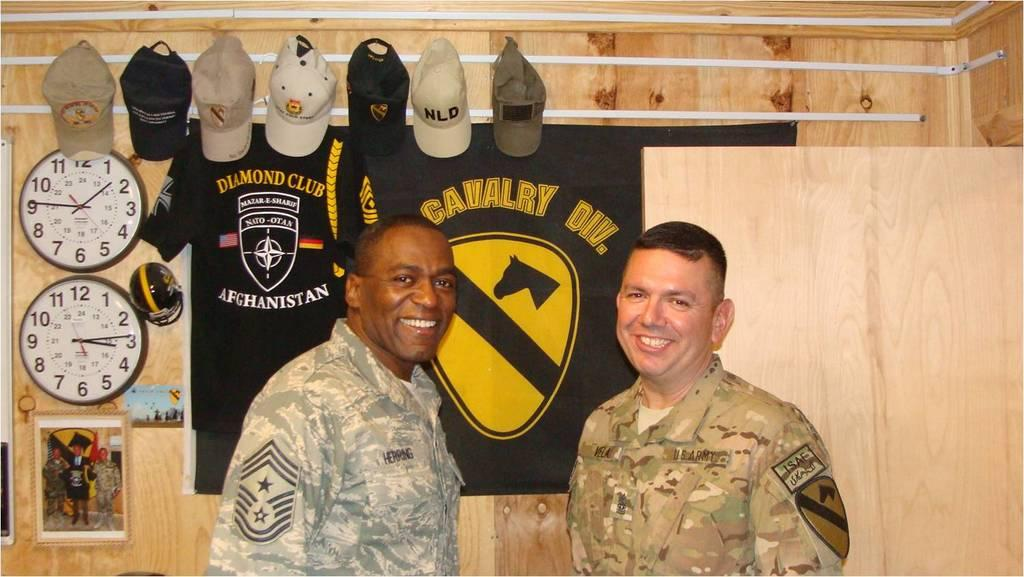<image>
Summarize the visual content of the image. Two uniformed men pose in front of a banner for a Cavalry Division. 